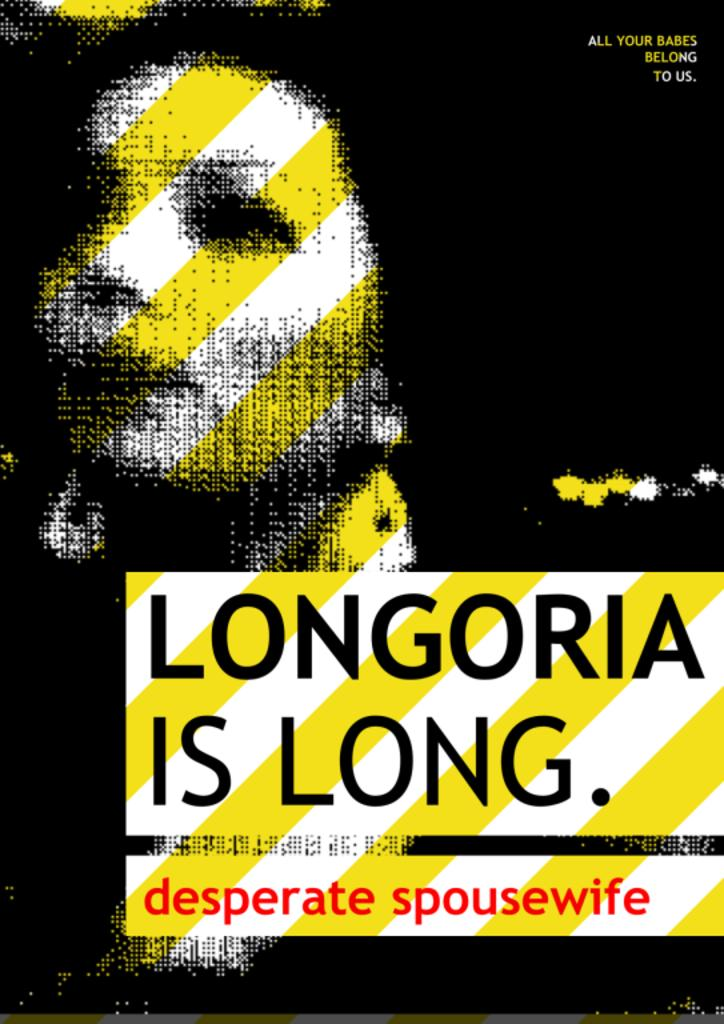<image>
Render a clear and concise summary of the photo. a sign says Longoria is Long with yellow slashes through it 